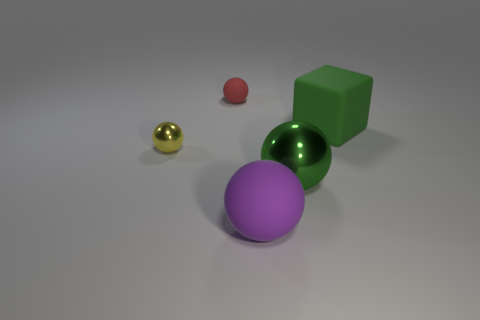What number of tiny green objects have the same shape as the purple object?
Keep it short and to the point. 0. There is a metallic thing that is to the right of the matte thing left of the large purple rubber thing; what is its shape?
Provide a short and direct response. Sphere. Is the size of the ball that is left of the red thing the same as the large green ball?
Keep it short and to the point. No. There is a matte thing that is both on the left side of the big shiny ball and behind the yellow metal object; what size is it?
Offer a terse response. Small. What number of purple things are the same size as the red rubber ball?
Give a very brief answer. 0. What number of matte cubes are behind the green metal sphere right of the large purple rubber object?
Ensure brevity in your answer.  1. There is a large object that is on the left side of the big shiny ball; is it the same color as the large cube?
Offer a very short reply. No. There is a matte ball that is behind the big matte thing that is to the left of the big rubber cube; is there a tiny ball that is right of it?
Give a very brief answer. No. There is a matte thing that is behind the large green sphere and left of the large green matte object; what shape is it?
Offer a terse response. Sphere. Are there any big shiny balls of the same color as the small metal thing?
Your answer should be compact. No. 